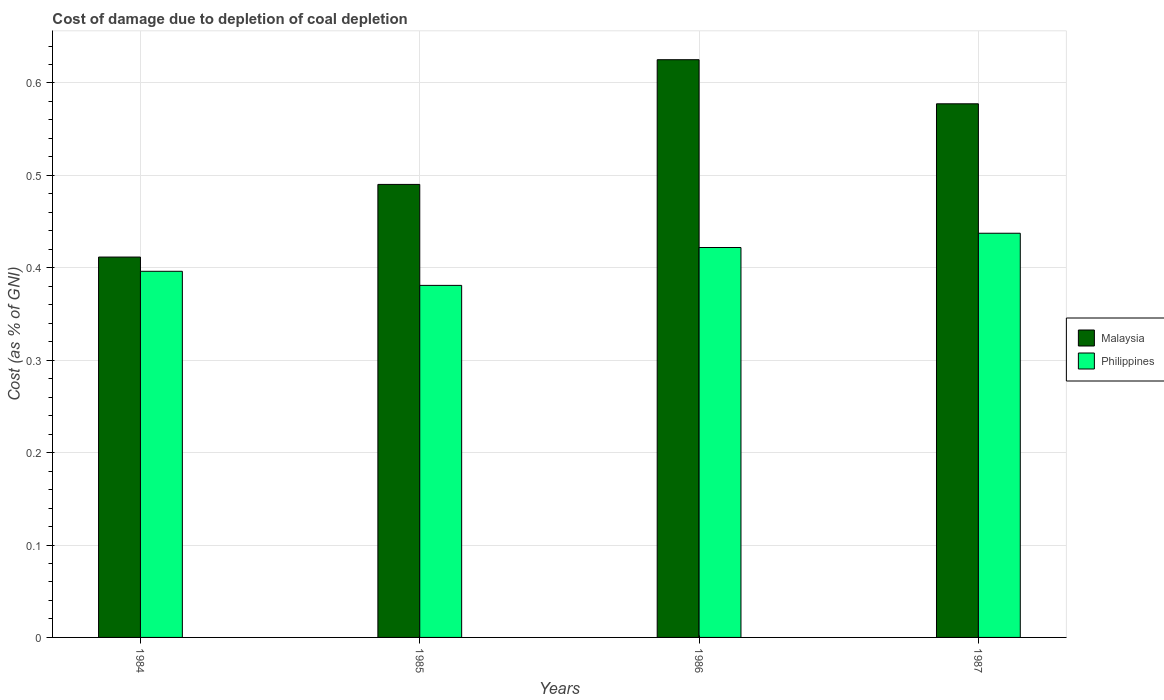How many groups of bars are there?
Your answer should be compact. 4. Are the number of bars per tick equal to the number of legend labels?
Offer a terse response. Yes. Are the number of bars on each tick of the X-axis equal?
Your answer should be compact. Yes. How many bars are there on the 1st tick from the left?
Offer a terse response. 2. What is the cost of damage caused due to coal depletion in Malaysia in 1986?
Provide a short and direct response. 0.63. Across all years, what is the maximum cost of damage caused due to coal depletion in Philippines?
Your answer should be compact. 0.44. Across all years, what is the minimum cost of damage caused due to coal depletion in Malaysia?
Ensure brevity in your answer.  0.41. In which year was the cost of damage caused due to coal depletion in Philippines maximum?
Make the answer very short. 1987. What is the total cost of damage caused due to coal depletion in Philippines in the graph?
Ensure brevity in your answer.  1.64. What is the difference between the cost of damage caused due to coal depletion in Malaysia in 1984 and that in 1987?
Give a very brief answer. -0.17. What is the difference between the cost of damage caused due to coal depletion in Malaysia in 1986 and the cost of damage caused due to coal depletion in Philippines in 1984?
Your answer should be very brief. 0.23. What is the average cost of damage caused due to coal depletion in Malaysia per year?
Offer a very short reply. 0.53. In the year 1986, what is the difference between the cost of damage caused due to coal depletion in Philippines and cost of damage caused due to coal depletion in Malaysia?
Make the answer very short. -0.2. In how many years, is the cost of damage caused due to coal depletion in Malaysia greater than 0.48000000000000004 %?
Keep it short and to the point. 3. What is the ratio of the cost of damage caused due to coal depletion in Malaysia in 1985 to that in 1987?
Ensure brevity in your answer.  0.85. Is the cost of damage caused due to coal depletion in Philippines in 1986 less than that in 1987?
Your answer should be very brief. Yes. What is the difference between the highest and the second highest cost of damage caused due to coal depletion in Philippines?
Your answer should be very brief. 0.02. What is the difference between the highest and the lowest cost of damage caused due to coal depletion in Philippines?
Your response must be concise. 0.06. In how many years, is the cost of damage caused due to coal depletion in Philippines greater than the average cost of damage caused due to coal depletion in Philippines taken over all years?
Ensure brevity in your answer.  2. Is the sum of the cost of damage caused due to coal depletion in Philippines in 1984 and 1986 greater than the maximum cost of damage caused due to coal depletion in Malaysia across all years?
Offer a very short reply. Yes. What does the 2nd bar from the right in 1987 represents?
Ensure brevity in your answer.  Malaysia. How many bars are there?
Your response must be concise. 8. Are all the bars in the graph horizontal?
Your answer should be very brief. No. How many years are there in the graph?
Offer a terse response. 4. What is the difference between two consecutive major ticks on the Y-axis?
Your answer should be very brief. 0.1. Are the values on the major ticks of Y-axis written in scientific E-notation?
Provide a short and direct response. No. Where does the legend appear in the graph?
Keep it short and to the point. Center right. What is the title of the graph?
Provide a succinct answer. Cost of damage due to depletion of coal depletion. What is the label or title of the Y-axis?
Provide a short and direct response. Cost (as % of GNI). What is the Cost (as % of GNI) of Malaysia in 1984?
Provide a succinct answer. 0.41. What is the Cost (as % of GNI) in Philippines in 1984?
Your answer should be compact. 0.4. What is the Cost (as % of GNI) in Malaysia in 1985?
Provide a short and direct response. 0.49. What is the Cost (as % of GNI) in Philippines in 1985?
Your answer should be very brief. 0.38. What is the Cost (as % of GNI) of Malaysia in 1986?
Your answer should be compact. 0.63. What is the Cost (as % of GNI) of Philippines in 1986?
Your answer should be very brief. 0.42. What is the Cost (as % of GNI) of Malaysia in 1987?
Provide a succinct answer. 0.58. What is the Cost (as % of GNI) in Philippines in 1987?
Your answer should be compact. 0.44. Across all years, what is the maximum Cost (as % of GNI) of Malaysia?
Offer a very short reply. 0.63. Across all years, what is the maximum Cost (as % of GNI) of Philippines?
Provide a succinct answer. 0.44. Across all years, what is the minimum Cost (as % of GNI) of Malaysia?
Keep it short and to the point. 0.41. Across all years, what is the minimum Cost (as % of GNI) of Philippines?
Ensure brevity in your answer.  0.38. What is the total Cost (as % of GNI) of Malaysia in the graph?
Offer a very short reply. 2.1. What is the total Cost (as % of GNI) of Philippines in the graph?
Give a very brief answer. 1.64. What is the difference between the Cost (as % of GNI) in Malaysia in 1984 and that in 1985?
Provide a succinct answer. -0.08. What is the difference between the Cost (as % of GNI) of Philippines in 1984 and that in 1985?
Offer a terse response. 0.02. What is the difference between the Cost (as % of GNI) of Malaysia in 1984 and that in 1986?
Give a very brief answer. -0.21. What is the difference between the Cost (as % of GNI) of Philippines in 1984 and that in 1986?
Offer a very short reply. -0.03. What is the difference between the Cost (as % of GNI) in Malaysia in 1984 and that in 1987?
Provide a short and direct response. -0.17. What is the difference between the Cost (as % of GNI) in Philippines in 1984 and that in 1987?
Offer a terse response. -0.04. What is the difference between the Cost (as % of GNI) of Malaysia in 1985 and that in 1986?
Ensure brevity in your answer.  -0.13. What is the difference between the Cost (as % of GNI) in Philippines in 1985 and that in 1986?
Offer a very short reply. -0.04. What is the difference between the Cost (as % of GNI) of Malaysia in 1985 and that in 1987?
Give a very brief answer. -0.09. What is the difference between the Cost (as % of GNI) in Philippines in 1985 and that in 1987?
Make the answer very short. -0.06. What is the difference between the Cost (as % of GNI) of Malaysia in 1986 and that in 1987?
Your answer should be compact. 0.05. What is the difference between the Cost (as % of GNI) of Philippines in 1986 and that in 1987?
Your response must be concise. -0.02. What is the difference between the Cost (as % of GNI) in Malaysia in 1984 and the Cost (as % of GNI) in Philippines in 1985?
Make the answer very short. 0.03. What is the difference between the Cost (as % of GNI) in Malaysia in 1984 and the Cost (as % of GNI) in Philippines in 1986?
Offer a terse response. -0.01. What is the difference between the Cost (as % of GNI) of Malaysia in 1984 and the Cost (as % of GNI) of Philippines in 1987?
Make the answer very short. -0.03. What is the difference between the Cost (as % of GNI) in Malaysia in 1985 and the Cost (as % of GNI) in Philippines in 1986?
Keep it short and to the point. 0.07. What is the difference between the Cost (as % of GNI) in Malaysia in 1985 and the Cost (as % of GNI) in Philippines in 1987?
Ensure brevity in your answer.  0.05. What is the difference between the Cost (as % of GNI) of Malaysia in 1986 and the Cost (as % of GNI) of Philippines in 1987?
Your response must be concise. 0.19. What is the average Cost (as % of GNI) in Malaysia per year?
Give a very brief answer. 0.53. What is the average Cost (as % of GNI) of Philippines per year?
Your response must be concise. 0.41. In the year 1984, what is the difference between the Cost (as % of GNI) in Malaysia and Cost (as % of GNI) in Philippines?
Your response must be concise. 0.02. In the year 1985, what is the difference between the Cost (as % of GNI) in Malaysia and Cost (as % of GNI) in Philippines?
Make the answer very short. 0.11. In the year 1986, what is the difference between the Cost (as % of GNI) of Malaysia and Cost (as % of GNI) of Philippines?
Offer a very short reply. 0.2. In the year 1987, what is the difference between the Cost (as % of GNI) of Malaysia and Cost (as % of GNI) of Philippines?
Provide a succinct answer. 0.14. What is the ratio of the Cost (as % of GNI) in Malaysia in 1984 to that in 1985?
Provide a short and direct response. 0.84. What is the ratio of the Cost (as % of GNI) of Philippines in 1984 to that in 1985?
Give a very brief answer. 1.04. What is the ratio of the Cost (as % of GNI) in Malaysia in 1984 to that in 1986?
Offer a terse response. 0.66. What is the ratio of the Cost (as % of GNI) in Philippines in 1984 to that in 1986?
Offer a terse response. 0.94. What is the ratio of the Cost (as % of GNI) of Malaysia in 1984 to that in 1987?
Ensure brevity in your answer.  0.71. What is the ratio of the Cost (as % of GNI) in Philippines in 1984 to that in 1987?
Keep it short and to the point. 0.91. What is the ratio of the Cost (as % of GNI) in Malaysia in 1985 to that in 1986?
Keep it short and to the point. 0.78. What is the ratio of the Cost (as % of GNI) of Philippines in 1985 to that in 1986?
Your answer should be very brief. 0.9. What is the ratio of the Cost (as % of GNI) in Malaysia in 1985 to that in 1987?
Your response must be concise. 0.85. What is the ratio of the Cost (as % of GNI) of Philippines in 1985 to that in 1987?
Make the answer very short. 0.87. What is the ratio of the Cost (as % of GNI) of Malaysia in 1986 to that in 1987?
Provide a succinct answer. 1.08. What is the ratio of the Cost (as % of GNI) of Philippines in 1986 to that in 1987?
Provide a short and direct response. 0.96. What is the difference between the highest and the second highest Cost (as % of GNI) of Malaysia?
Provide a short and direct response. 0.05. What is the difference between the highest and the second highest Cost (as % of GNI) in Philippines?
Your answer should be very brief. 0.02. What is the difference between the highest and the lowest Cost (as % of GNI) of Malaysia?
Ensure brevity in your answer.  0.21. What is the difference between the highest and the lowest Cost (as % of GNI) of Philippines?
Your response must be concise. 0.06. 